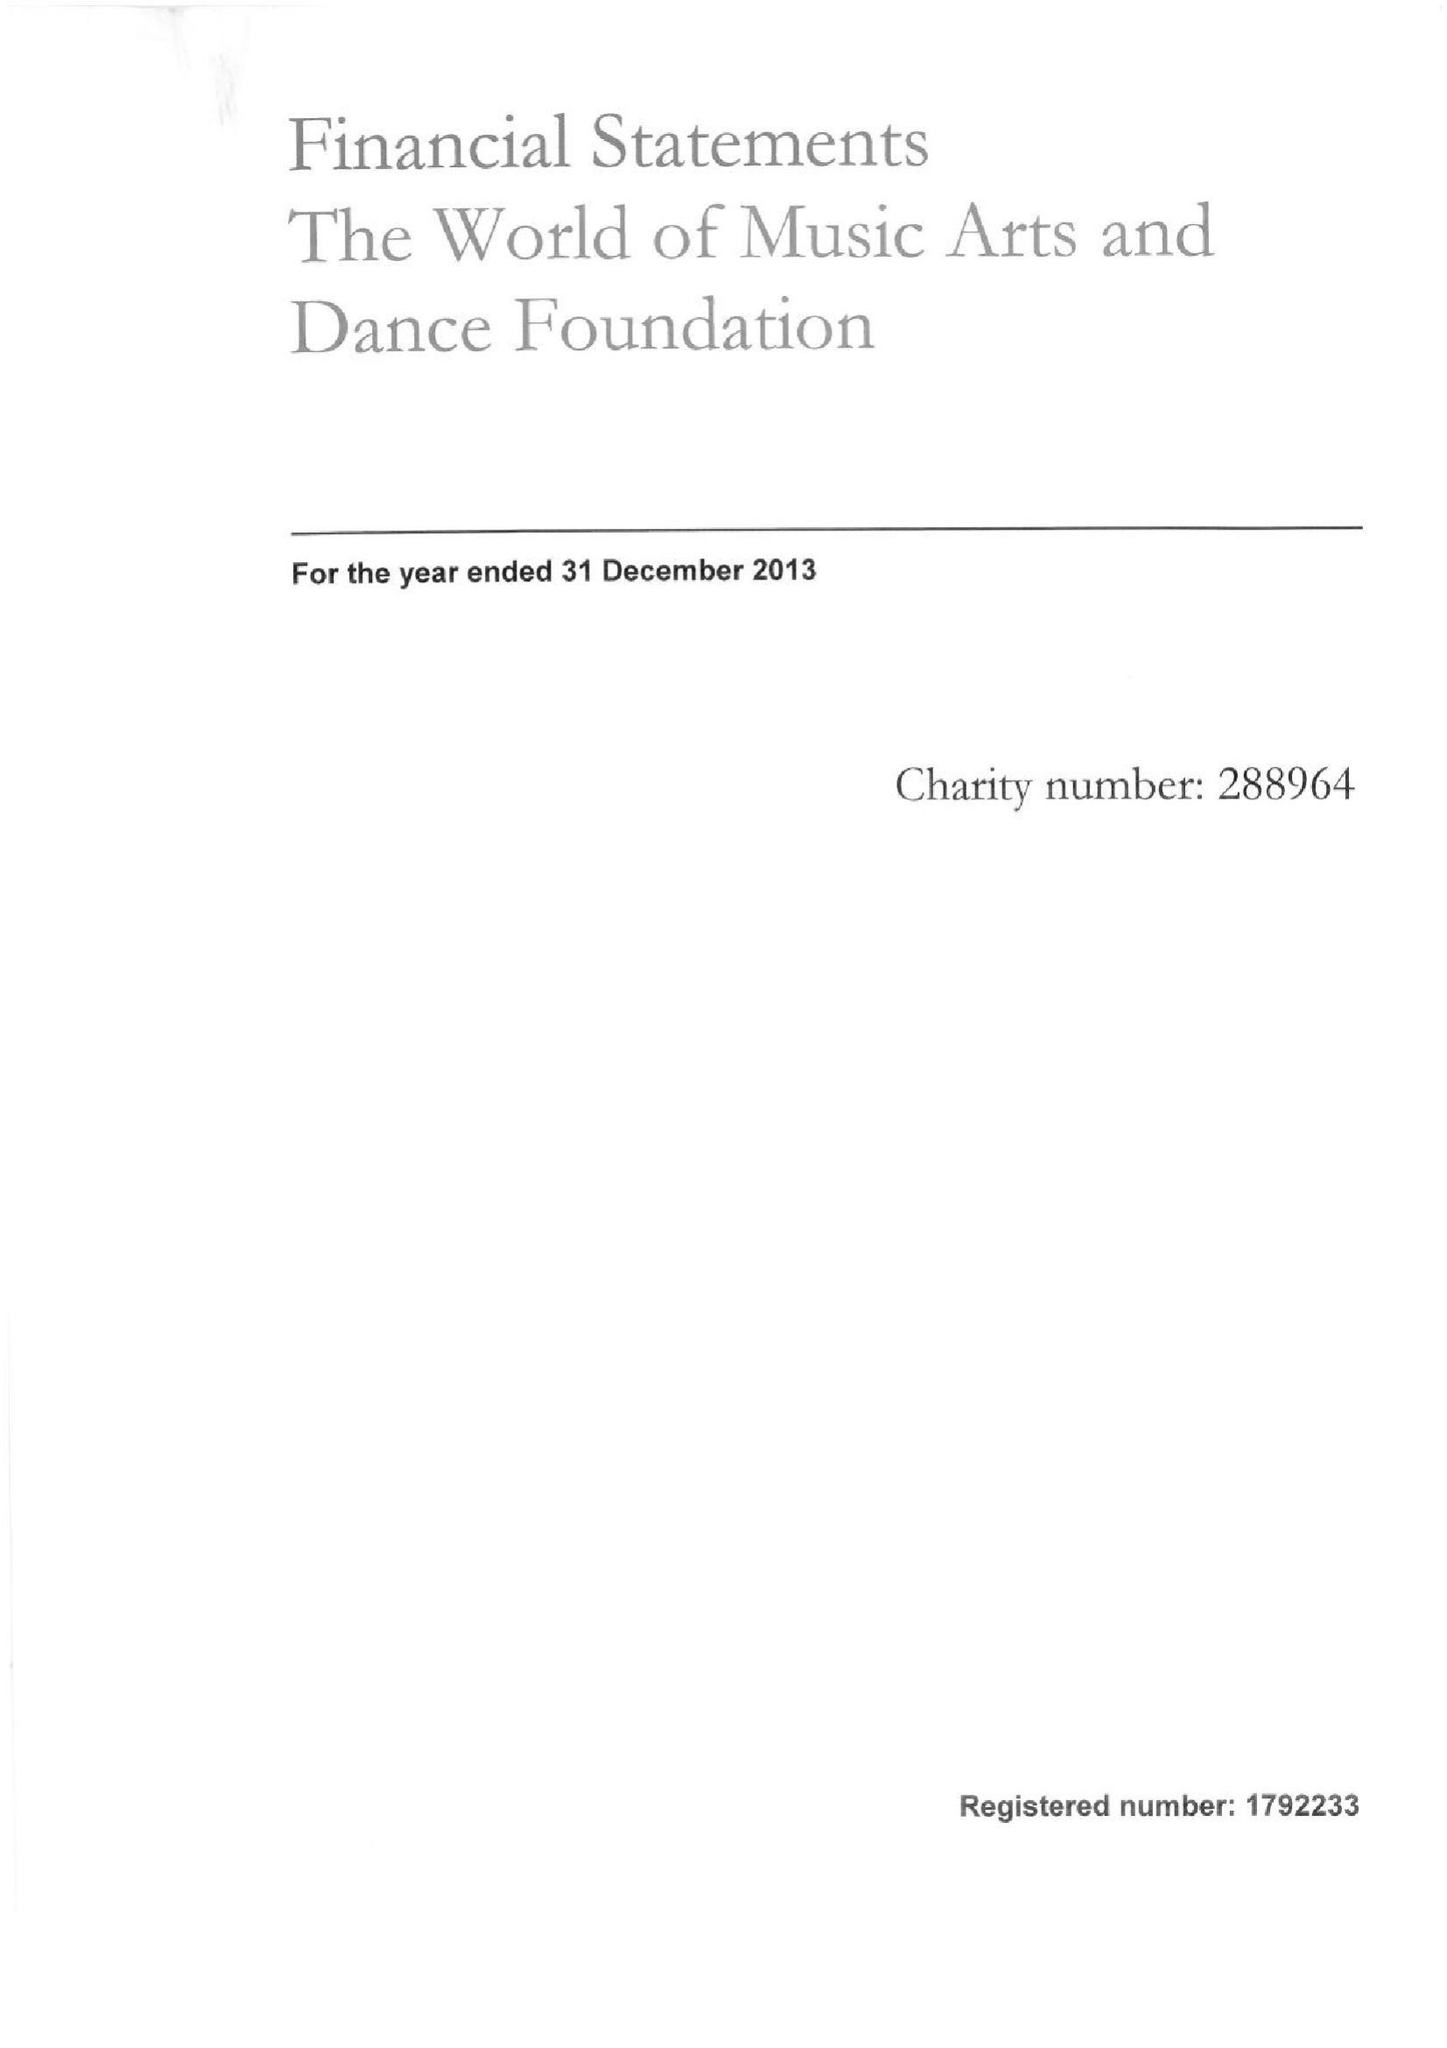What is the value for the report_date?
Answer the question using a single word or phrase. 2013-12-31 